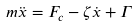<formula> <loc_0><loc_0><loc_500><loc_500>m \ddot { x } = F _ { c } - \zeta \dot { x } + \Gamma</formula> 